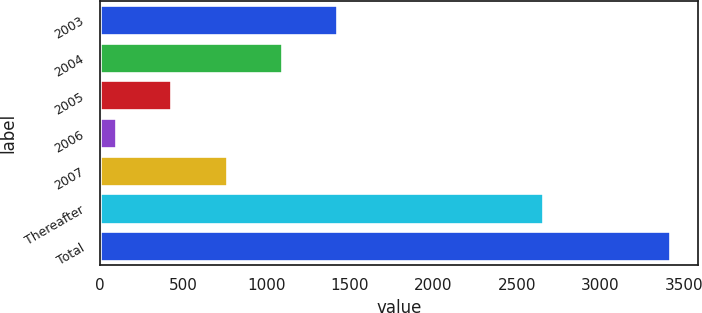Convert chart. <chart><loc_0><loc_0><loc_500><loc_500><bar_chart><fcel>2003<fcel>2004<fcel>2005<fcel>2006<fcel>2007<fcel>Thereafter<fcel>Total<nl><fcel>1423.6<fcel>1091.7<fcel>427.9<fcel>96<fcel>759.8<fcel>2659<fcel>3415<nl></chart> 